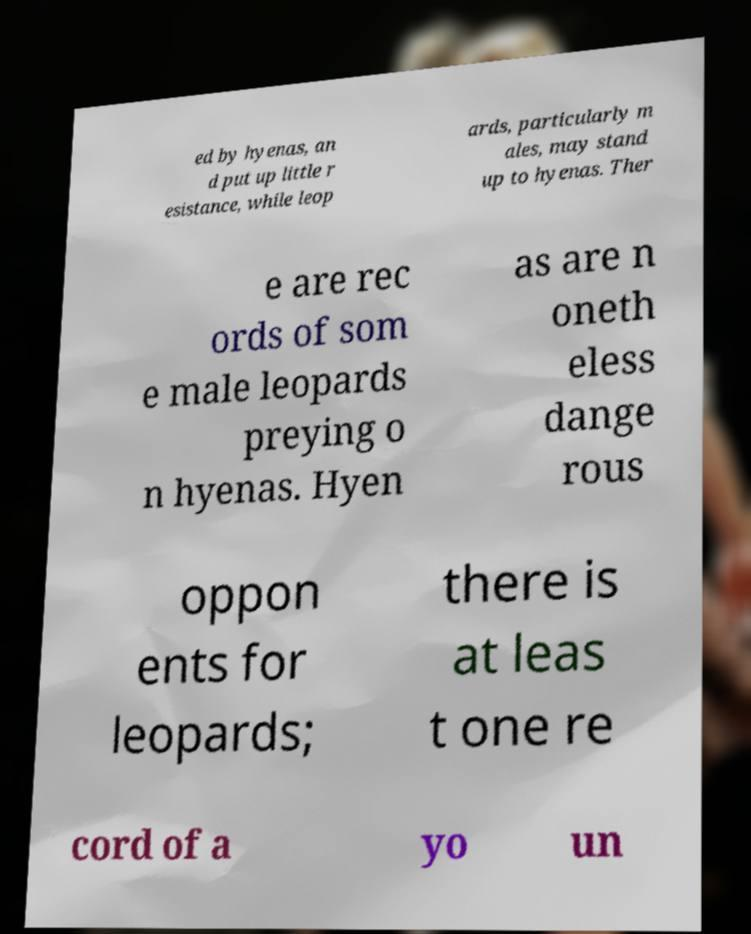Please identify and transcribe the text found in this image. ed by hyenas, an d put up little r esistance, while leop ards, particularly m ales, may stand up to hyenas. Ther e are rec ords of som e male leopards preying o n hyenas. Hyen as are n oneth eless dange rous oppon ents for leopards; there is at leas t one re cord of a yo un 